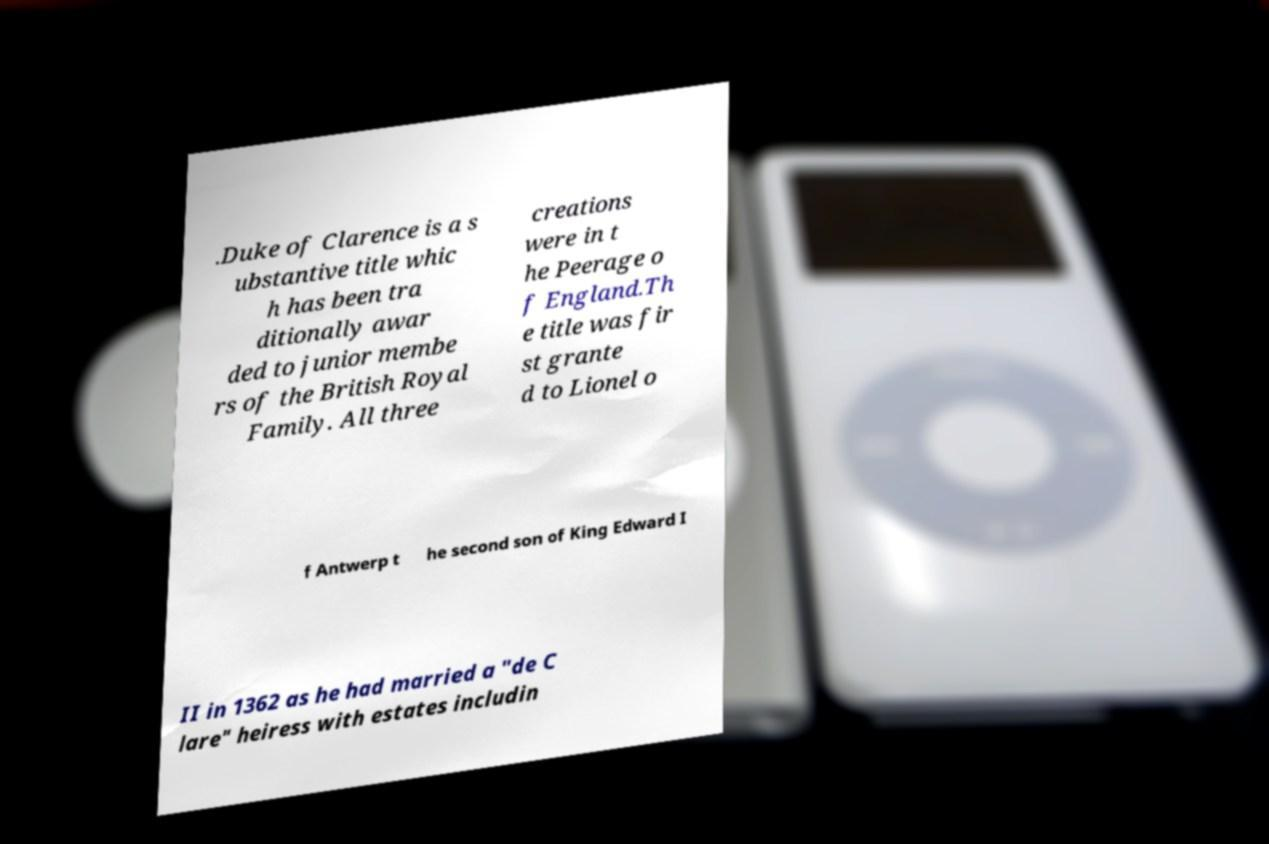What messages or text are displayed in this image? I need them in a readable, typed format. .Duke of Clarence is a s ubstantive title whic h has been tra ditionally awar ded to junior membe rs of the British Royal Family. All three creations were in t he Peerage o f England.Th e title was fir st grante d to Lionel o f Antwerp t he second son of King Edward I II in 1362 as he had married a "de C lare" heiress with estates includin 